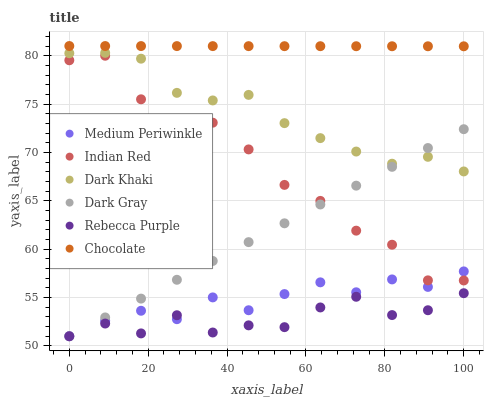Does Rebecca Purple have the minimum area under the curve?
Answer yes or no. Yes. Does Chocolate have the maximum area under the curve?
Answer yes or no. Yes. Does Medium Periwinkle have the minimum area under the curve?
Answer yes or no. No. Does Medium Periwinkle have the maximum area under the curve?
Answer yes or no. No. Is Chocolate the smoothest?
Answer yes or no. Yes. Is Indian Red the roughest?
Answer yes or no. Yes. Is Medium Periwinkle the smoothest?
Answer yes or no. No. Is Medium Periwinkle the roughest?
Answer yes or no. No. Does Dark Gray have the lowest value?
Answer yes or no. Yes. Does Chocolate have the lowest value?
Answer yes or no. No. Does Chocolate have the highest value?
Answer yes or no. Yes. Does Medium Periwinkle have the highest value?
Answer yes or no. No. Is Medium Periwinkle less than Dark Khaki?
Answer yes or no. Yes. Is Chocolate greater than Indian Red?
Answer yes or no. Yes. Does Dark Gray intersect Rebecca Purple?
Answer yes or no. Yes. Is Dark Gray less than Rebecca Purple?
Answer yes or no. No. Is Dark Gray greater than Rebecca Purple?
Answer yes or no. No. Does Medium Periwinkle intersect Dark Khaki?
Answer yes or no. No. 